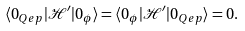Convert formula to latex. <formula><loc_0><loc_0><loc_500><loc_500>\langle 0 _ { Q e p } | \mathcal { H } ^ { \prime } | 0 _ { \phi } \rangle = \langle 0 _ { \phi } | \mathcal { H } ^ { \prime } | 0 _ { Q e p } \rangle = 0 .</formula> 